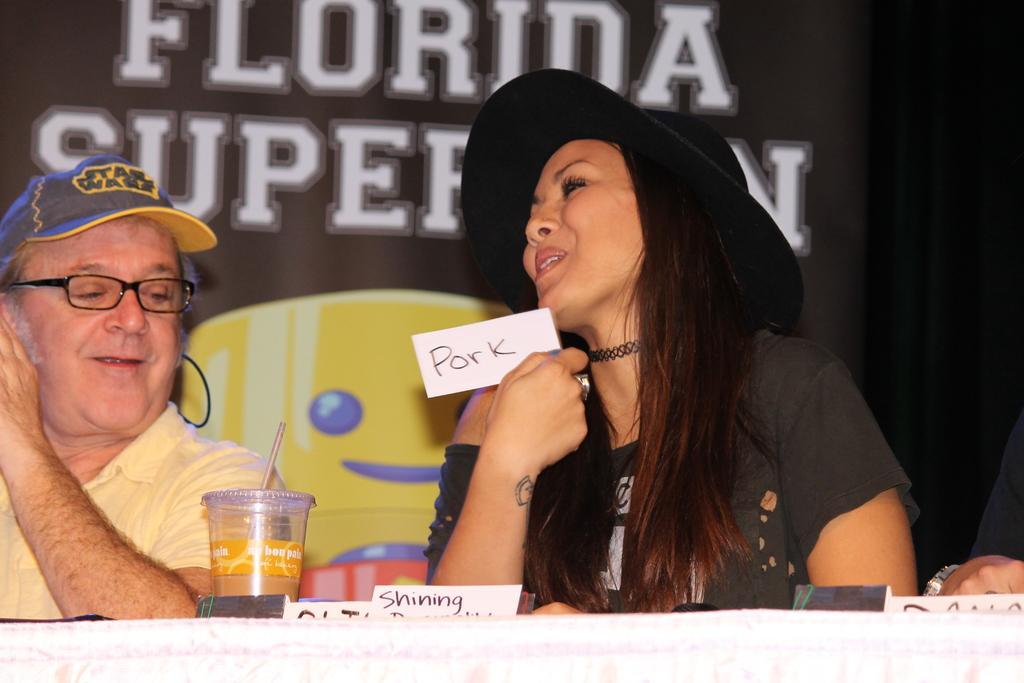Could you give a brief overview of what you see in this image? In this image there are three people sitting, one of them is holding a paper with some text on it, in front of them there is a table with some nameplates and juice on it. In the background there is a banner with some text and an image on it. 